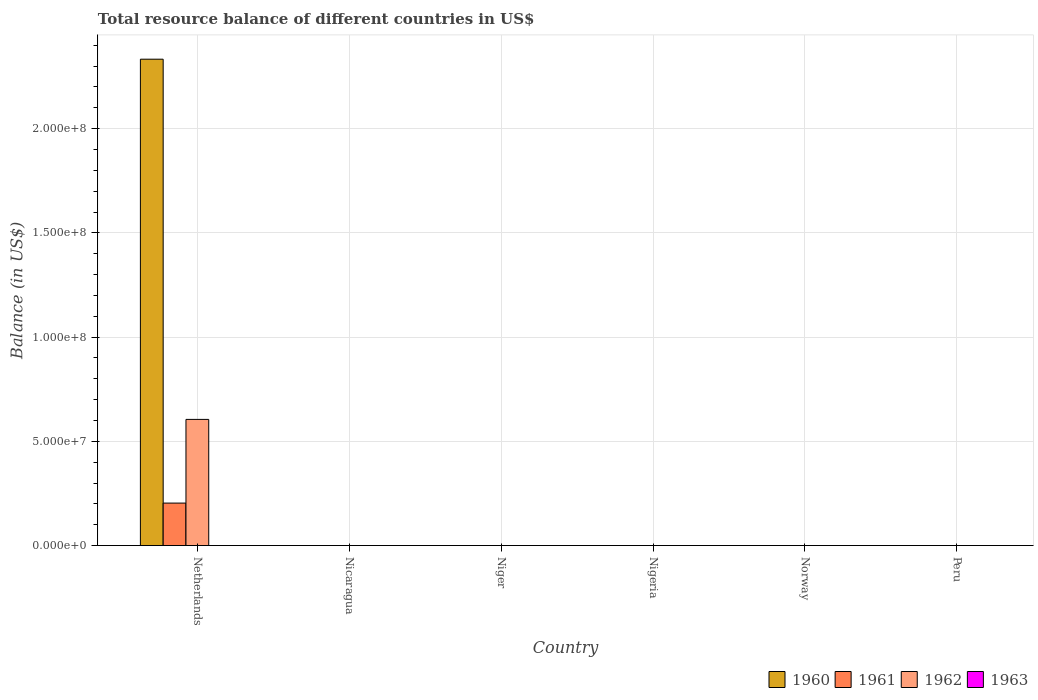How many different coloured bars are there?
Give a very brief answer. 3. Are the number of bars per tick equal to the number of legend labels?
Your response must be concise. No. Are the number of bars on each tick of the X-axis equal?
Offer a terse response. No. How many bars are there on the 4th tick from the right?
Give a very brief answer. 0. What is the label of the 3rd group of bars from the left?
Make the answer very short. Niger. What is the total resource balance in 1960 in Netherlands?
Ensure brevity in your answer.  2.33e+08. Across all countries, what is the maximum total resource balance in 1962?
Keep it short and to the point. 6.05e+07. Across all countries, what is the minimum total resource balance in 1961?
Your response must be concise. 0. In which country was the total resource balance in 1961 maximum?
Your answer should be compact. Netherlands. What is the total total resource balance in 1960 in the graph?
Make the answer very short. 2.33e+08. What is the difference between the total resource balance in 1962 in Niger and the total resource balance in 1960 in Nigeria?
Keep it short and to the point. 0. What is the average total resource balance in 1960 per country?
Your answer should be very brief. 3.89e+07. What is the difference between the total resource balance of/in 1961 and total resource balance of/in 1960 in Netherlands?
Offer a terse response. -2.13e+08. In how many countries, is the total resource balance in 1961 greater than 70000000 US$?
Ensure brevity in your answer.  0. What is the difference between the highest and the lowest total resource balance in 1962?
Ensure brevity in your answer.  6.05e+07. In how many countries, is the total resource balance in 1960 greater than the average total resource balance in 1960 taken over all countries?
Ensure brevity in your answer.  1. Is it the case that in every country, the sum of the total resource balance in 1960 and total resource balance in 1962 is greater than the sum of total resource balance in 1963 and total resource balance in 1961?
Provide a succinct answer. No. How many countries are there in the graph?
Make the answer very short. 6. What is the difference between two consecutive major ticks on the Y-axis?
Offer a very short reply. 5.00e+07. Where does the legend appear in the graph?
Provide a short and direct response. Bottom right. How many legend labels are there?
Your response must be concise. 4. How are the legend labels stacked?
Your answer should be very brief. Horizontal. What is the title of the graph?
Your response must be concise. Total resource balance of different countries in US$. Does "2002" appear as one of the legend labels in the graph?
Keep it short and to the point. No. What is the label or title of the Y-axis?
Your response must be concise. Balance (in US$). What is the Balance (in US$) of 1960 in Netherlands?
Keep it short and to the point. 2.33e+08. What is the Balance (in US$) in 1961 in Netherlands?
Your answer should be very brief. 2.04e+07. What is the Balance (in US$) of 1962 in Netherlands?
Make the answer very short. 6.05e+07. What is the Balance (in US$) of 1960 in Nicaragua?
Your response must be concise. 0. What is the Balance (in US$) in 1962 in Nicaragua?
Your answer should be very brief. 0. What is the Balance (in US$) of 1963 in Nicaragua?
Your response must be concise. 0. What is the Balance (in US$) of 1960 in Niger?
Offer a very short reply. 0. What is the Balance (in US$) of 1961 in Nigeria?
Give a very brief answer. 0. What is the Balance (in US$) in 1962 in Nigeria?
Keep it short and to the point. 0. What is the Balance (in US$) in 1961 in Norway?
Offer a terse response. 0. What is the Balance (in US$) of 1962 in Norway?
Provide a succinct answer. 0. What is the Balance (in US$) in 1960 in Peru?
Offer a very short reply. 0. What is the Balance (in US$) in 1961 in Peru?
Your answer should be very brief. 0. What is the Balance (in US$) in 1962 in Peru?
Your answer should be very brief. 0. Across all countries, what is the maximum Balance (in US$) in 1960?
Your response must be concise. 2.33e+08. Across all countries, what is the maximum Balance (in US$) in 1961?
Offer a terse response. 2.04e+07. Across all countries, what is the maximum Balance (in US$) of 1962?
Your response must be concise. 6.05e+07. Across all countries, what is the minimum Balance (in US$) in 1960?
Offer a very short reply. 0. Across all countries, what is the minimum Balance (in US$) of 1961?
Keep it short and to the point. 0. What is the total Balance (in US$) in 1960 in the graph?
Your answer should be very brief. 2.33e+08. What is the total Balance (in US$) in 1961 in the graph?
Ensure brevity in your answer.  2.04e+07. What is the total Balance (in US$) of 1962 in the graph?
Your answer should be very brief. 6.05e+07. What is the total Balance (in US$) in 1963 in the graph?
Your response must be concise. 0. What is the average Balance (in US$) of 1960 per country?
Your response must be concise. 3.89e+07. What is the average Balance (in US$) of 1961 per country?
Provide a succinct answer. 3.40e+06. What is the average Balance (in US$) in 1962 per country?
Your answer should be compact. 1.01e+07. What is the average Balance (in US$) in 1963 per country?
Provide a succinct answer. 0. What is the difference between the Balance (in US$) in 1960 and Balance (in US$) in 1961 in Netherlands?
Make the answer very short. 2.13e+08. What is the difference between the Balance (in US$) of 1960 and Balance (in US$) of 1962 in Netherlands?
Your response must be concise. 1.73e+08. What is the difference between the Balance (in US$) in 1961 and Balance (in US$) in 1962 in Netherlands?
Your answer should be very brief. -4.01e+07. What is the difference between the highest and the lowest Balance (in US$) of 1960?
Offer a terse response. 2.33e+08. What is the difference between the highest and the lowest Balance (in US$) of 1961?
Your answer should be compact. 2.04e+07. What is the difference between the highest and the lowest Balance (in US$) in 1962?
Offer a very short reply. 6.05e+07. 